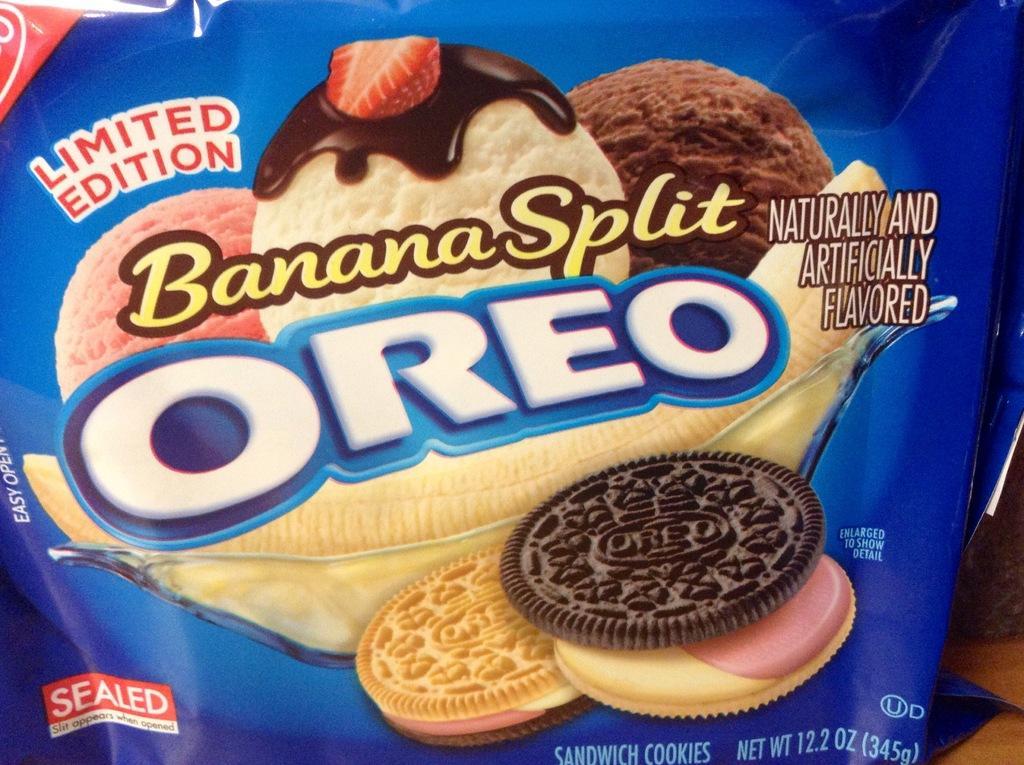How would you summarize this image in a sentence or two? A picture of a food packet. On this packet we can see ice cream scoops and cream biscuits. 